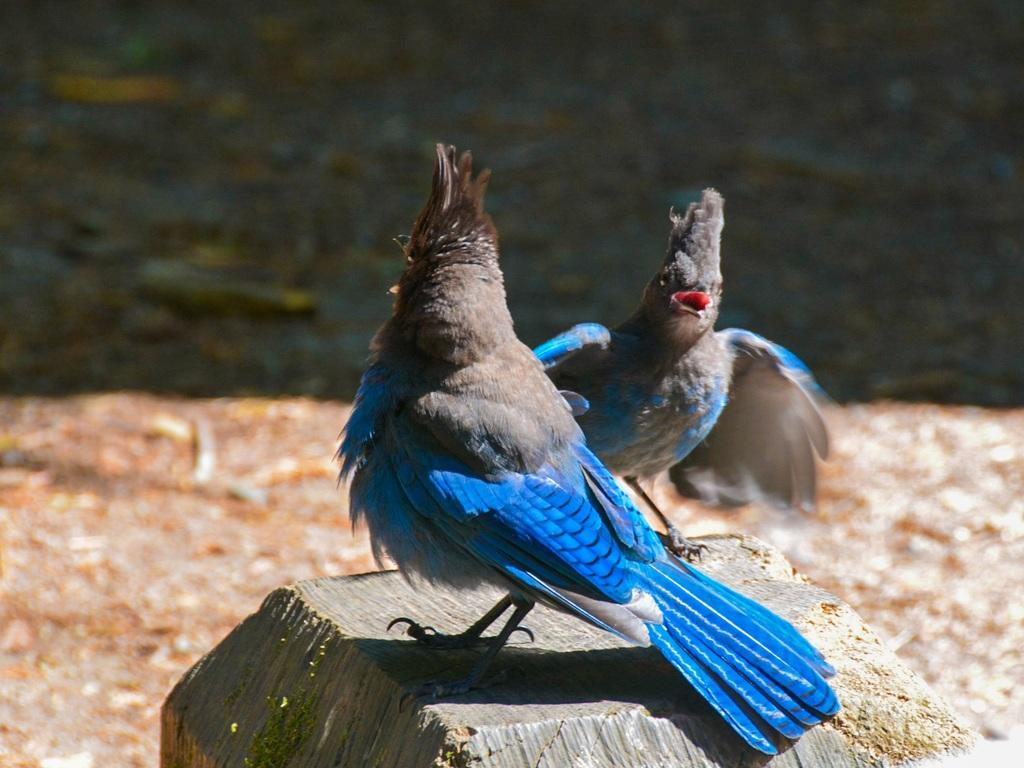How many birds are present in the image? There are two birds in the image. What colors can be seen on the birds? The birds are in black and blue colors. What surface are the birds standing on? The birds are standing on a wooden surface. Can you describe the background of the image? The background of the image is slightly blurred. What type of lead is the bird using to make selections in the image? There is no lead or selection process depicted in the image; it features two birds standing on a wooden surface. How many mouths can be seen in the image? There are no mouths visible in the image, as it only shows two birds standing on a wooden surface. 